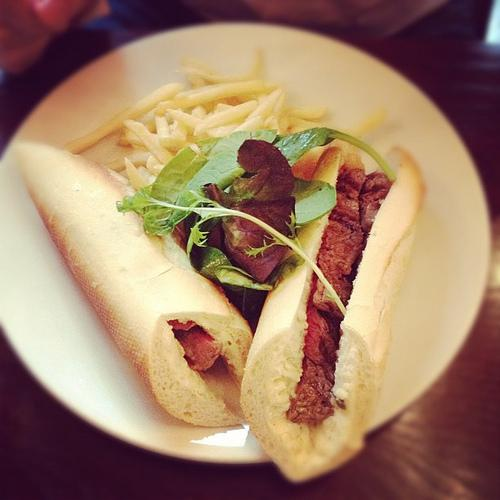Question: what is on top?
Choices:
A. Icing.
B. Sprinkles.
C. Ice cream.
D. Salad.
Answer with the letter. Answer: D Question: who would eat this?
Choices:
A. Horse.
B. Dog.
C. A human.
D. Cat.
Answer with the letter. Answer: C 